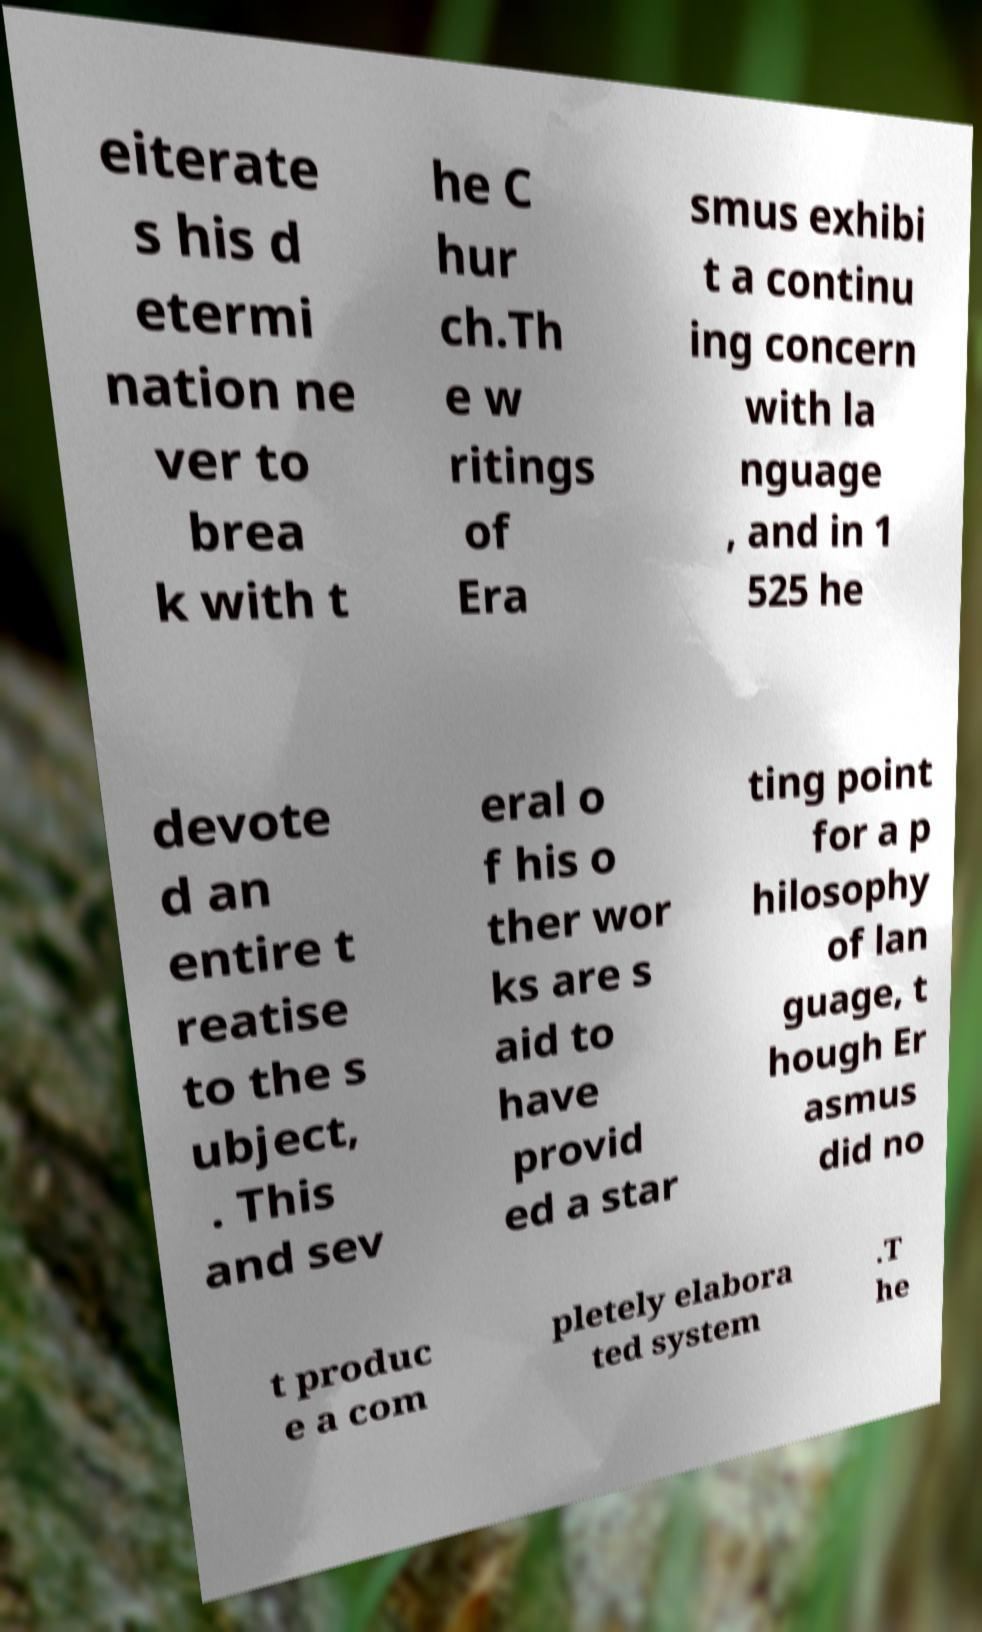Could you extract and type out the text from this image? eiterate s his d etermi nation ne ver to brea k with t he C hur ch.Th e w ritings of Era smus exhibi t a continu ing concern with la nguage , and in 1 525 he devote d an entire t reatise to the s ubject, . This and sev eral o f his o ther wor ks are s aid to have provid ed a star ting point for a p hilosophy of lan guage, t hough Er asmus did no t produc e a com pletely elabora ted system .T he 